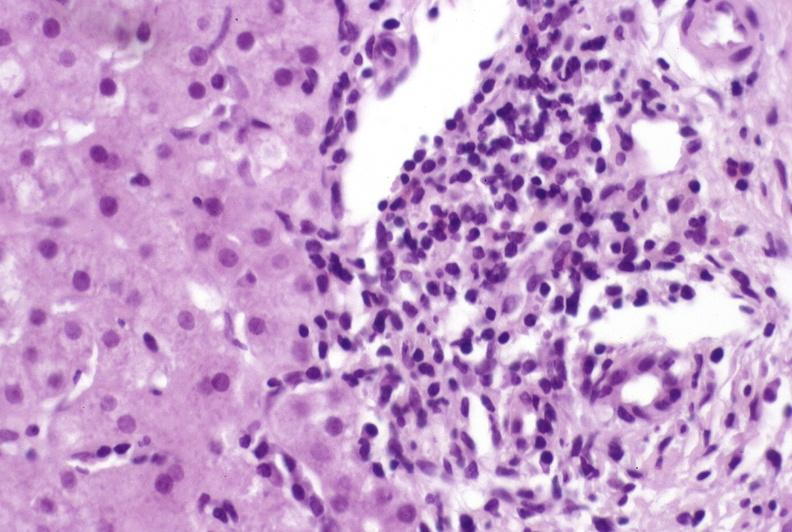s hepatobiliary present?
Answer the question using a single word or phrase. Yes 